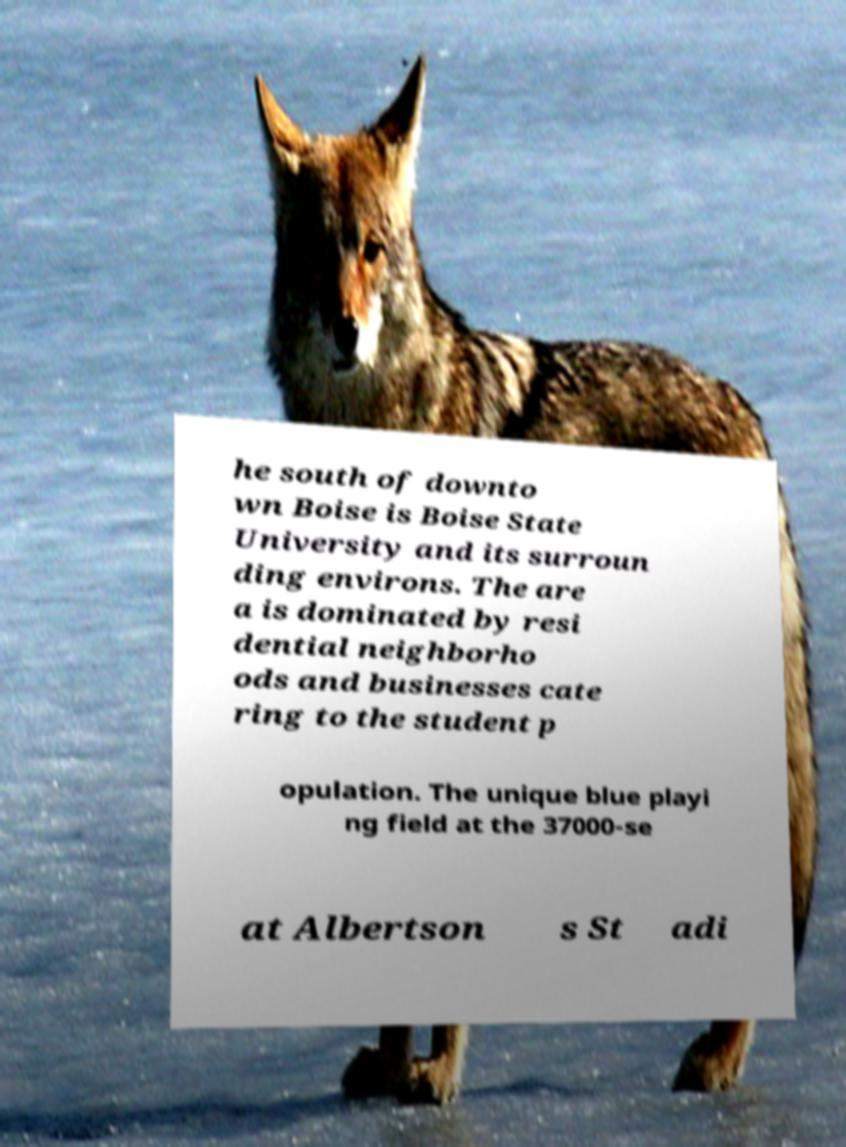I need the written content from this picture converted into text. Can you do that? he south of downto wn Boise is Boise State University and its surroun ding environs. The are a is dominated by resi dential neighborho ods and businesses cate ring to the student p opulation. The unique blue playi ng field at the 37000-se at Albertson s St adi 